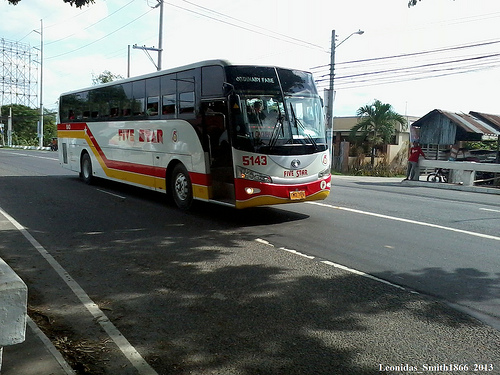How many buses are visible? There is one bus visible in the image, prominently displayed on the roadway. 